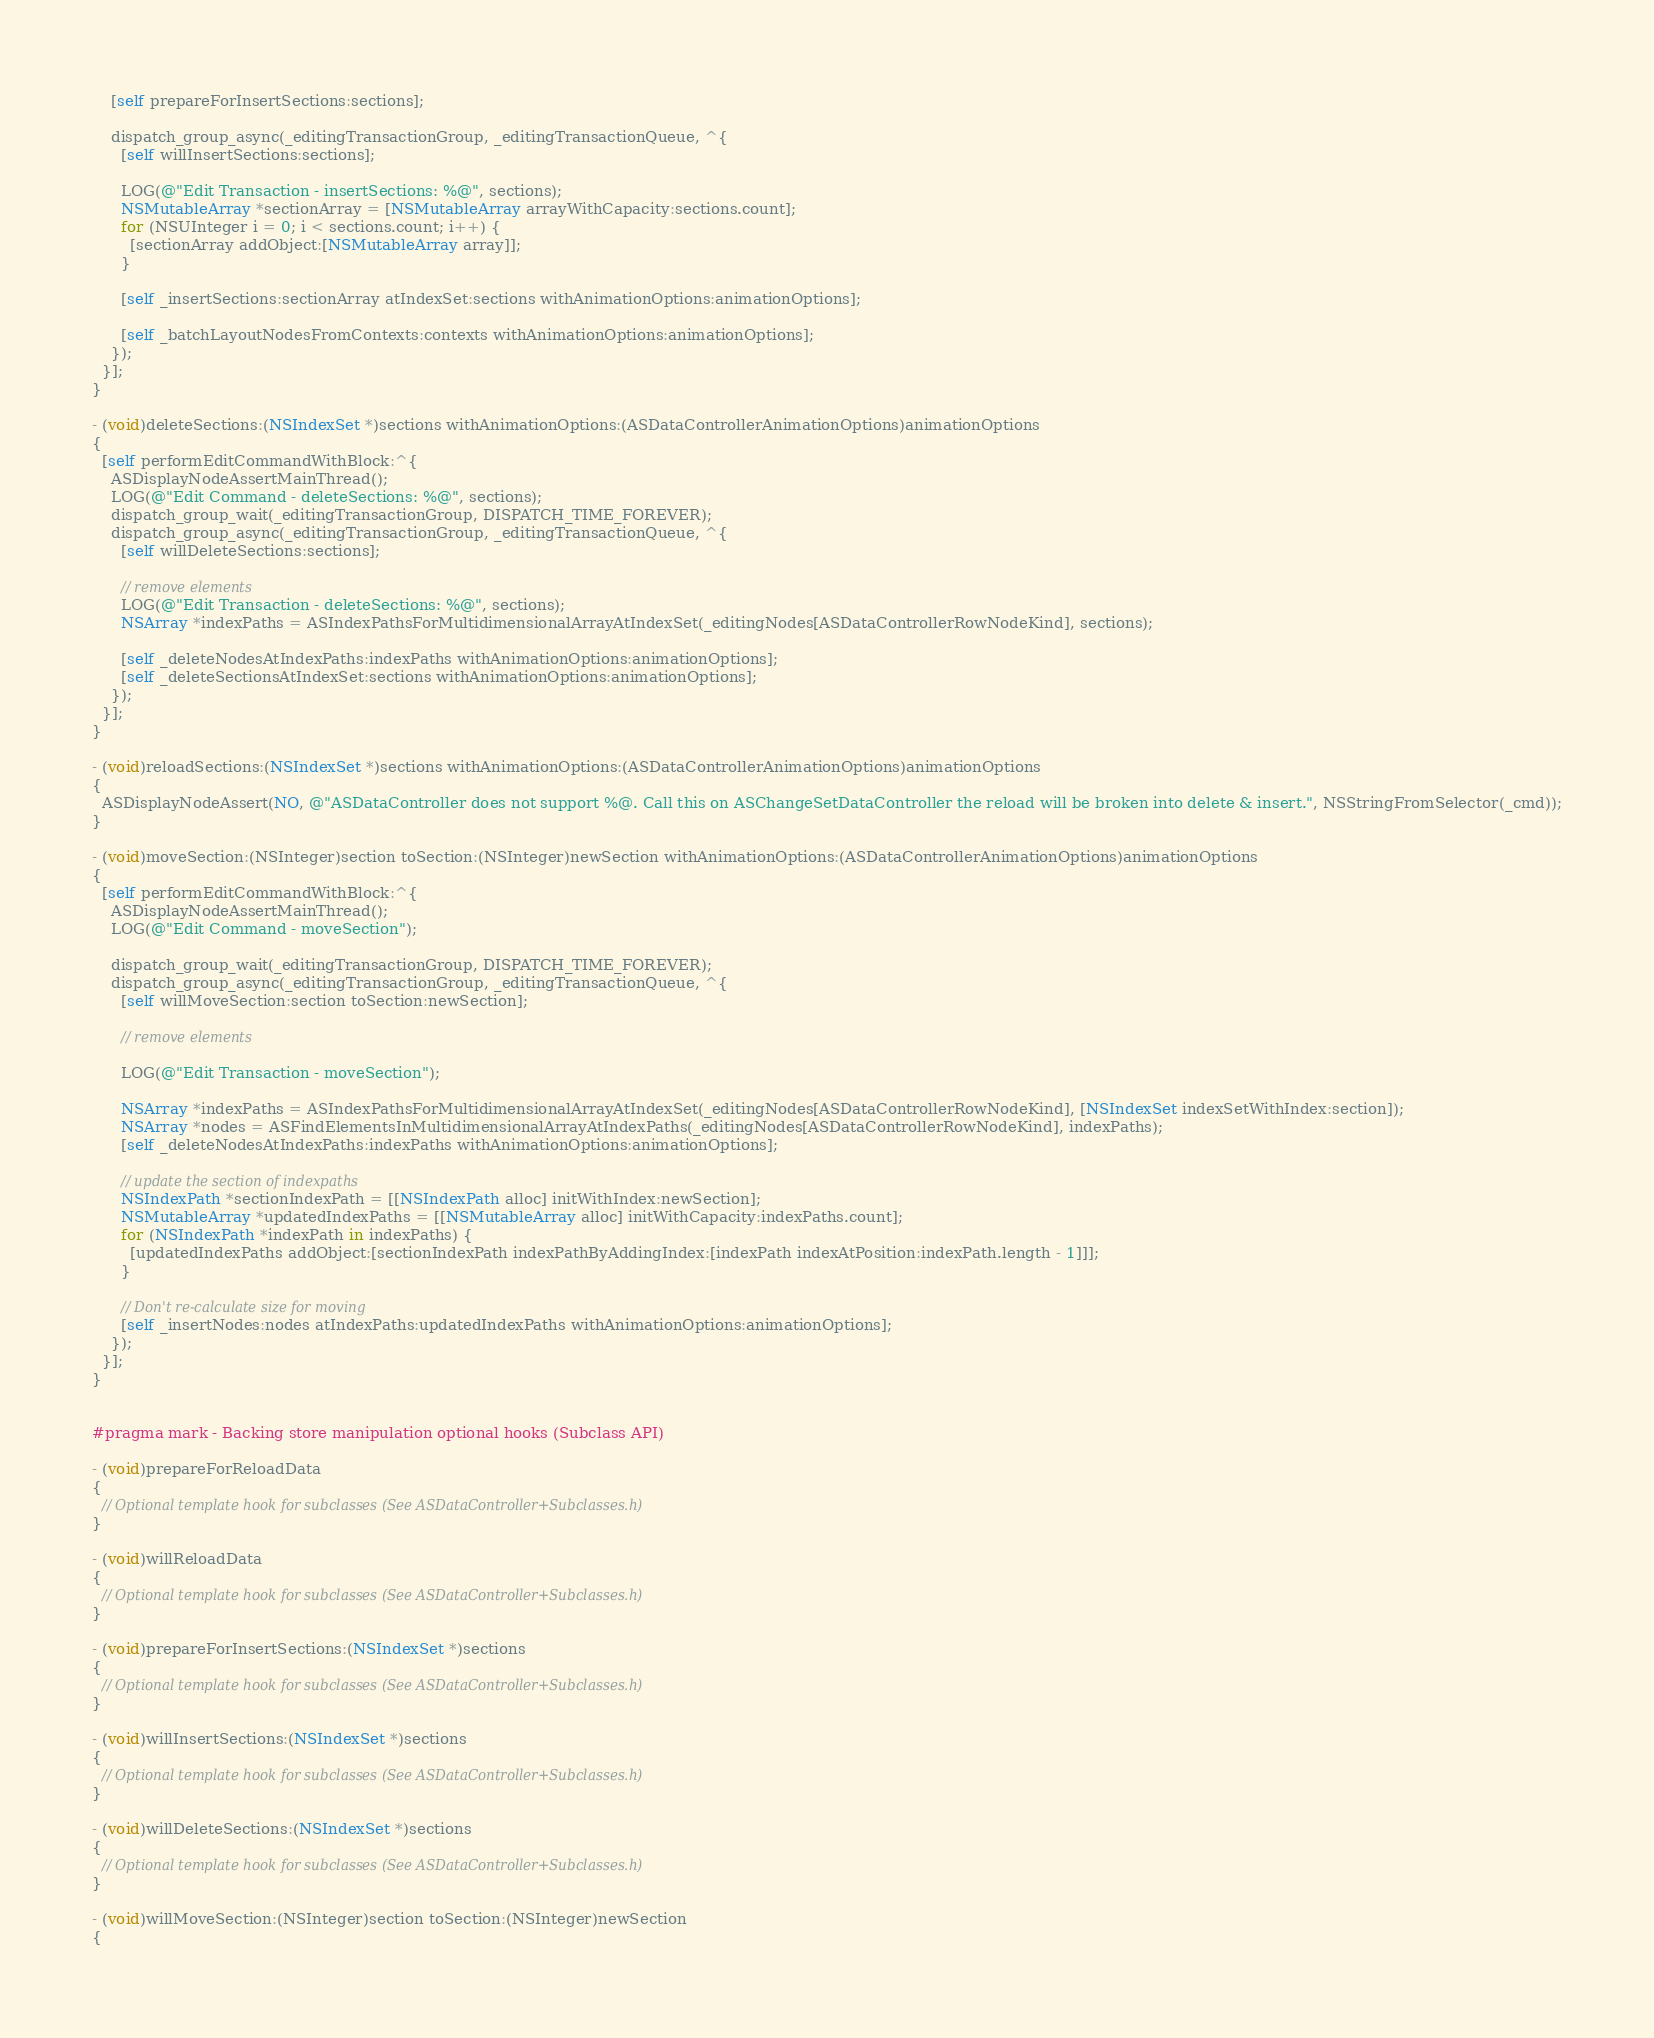<code> <loc_0><loc_0><loc_500><loc_500><_ObjectiveC_>    [self prepareForInsertSections:sections];
    
    dispatch_group_async(_editingTransactionGroup, _editingTransactionQueue, ^{
      [self willInsertSections:sections];

      LOG(@"Edit Transaction - insertSections: %@", sections);
      NSMutableArray *sectionArray = [NSMutableArray arrayWithCapacity:sections.count];
      for (NSUInteger i = 0; i < sections.count; i++) {
        [sectionArray addObject:[NSMutableArray array]];
      }

      [self _insertSections:sectionArray atIndexSet:sections withAnimationOptions:animationOptions];
      
      [self _batchLayoutNodesFromContexts:contexts withAnimationOptions:animationOptions];
    });
  }];
}

- (void)deleteSections:(NSIndexSet *)sections withAnimationOptions:(ASDataControllerAnimationOptions)animationOptions
{
  [self performEditCommandWithBlock:^{
    ASDisplayNodeAssertMainThread();
    LOG(@"Edit Command - deleteSections: %@", sections);
    dispatch_group_wait(_editingTransactionGroup, DISPATCH_TIME_FOREVER);
    dispatch_group_async(_editingTransactionGroup, _editingTransactionQueue, ^{
      [self willDeleteSections:sections];

      // remove elements
      LOG(@"Edit Transaction - deleteSections: %@", sections);
      NSArray *indexPaths = ASIndexPathsForMultidimensionalArrayAtIndexSet(_editingNodes[ASDataControllerRowNodeKind], sections);
      
      [self _deleteNodesAtIndexPaths:indexPaths withAnimationOptions:animationOptions];
      [self _deleteSectionsAtIndexSet:sections withAnimationOptions:animationOptions];
    });
  }];
}

- (void)reloadSections:(NSIndexSet *)sections withAnimationOptions:(ASDataControllerAnimationOptions)animationOptions
{
  ASDisplayNodeAssert(NO, @"ASDataController does not support %@. Call this on ASChangeSetDataController the reload will be broken into delete & insert.", NSStringFromSelector(_cmd));
}

- (void)moveSection:(NSInteger)section toSection:(NSInteger)newSection withAnimationOptions:(ASDataControllerAnimationOptions)animationOptions
{
  [self performEditCommandWithBlock:^{
    ASDisplayNodeAssertMainThread();
    LOG(@"Edit Command - moveSection");

    dispatch_group_wait(_editingTransactionGroup, DISPATCH_TIME_FOREVER);
    dispatch_group_async(_editingTransactionGroup, _editingTransactionQueue, ^{
      [self willMoveSection:section toSection:newSection];

      // remove elements
      
      LOG(@"Edit Transaction - moveSection");
      
      NSArray *indexPaths = ASIndexPathsForMultidimensionalArrayAtIndexSet(_editingNodes[ASDataControllerRowNodeKind], [NSIndexSet indexSetWithIndex:section]);
      NSArray *nodes = ASFindElementsInMultidimensionalArrayAtIndexPaths(_editingNodes[ASDataControllerRowNodeKind], indexPaths);
      [self _deleteNodesAtIndexPaths:indexPaths withAnimationOptions:animationOptions];

      // update the section of indexpaths
      NSIndexPath *sectionIndexPath = [[NSIndexPath alloc] initWithIndex:newSection];
      NSMutableArray *updatedIndexPaths = [[NSMutableArray alloc] initWithCapacity:indexPaths.count];
      for (NSIndexPath *indexPath in indexPaths) {
        [updatedIndexPaths addObject:[sectionIndexPath indexPathByAddingIndex:[indexPath indexAtPosition:indexPath.length - 1]]];
      }

      // Don't re-calculate size for moving
      [self _insertNodes:nodes atIndexPaths:updatedIndexPaths withAnimationOptions:animationOptions];
    });
  }];
}


#pragma mark - Backing store manipulation optional hooks (Subclass API)

- (void)prepareForReloadData
{
  // Optional template hook for subclasses (See ASDataController+Subclasses.h)
}

- (void)willReloadData
{
  // Optional template hook for subclasses (See ASDataController+Subclasses.h)
}

- (void)prepareForInsertSections:(NSIndexSet *)sections
{
  // Optional template hook for subclasses (See ASDataController+Subclasses.h)
}

- (void)willInsertSections:(NSIndexSet *)sections
{
  // Optional template hook for subclasses (See ASDataController+Subclasses.h)
}

- (void)willDeleteSections:(NSIndexSet *)sections
{
  // Optional template hook for subclasses (See ASDataController+Subclasses.h)
}

- (void)willMoveSection:(NSInteger)section toSection:(NSInteger)newSection
{</code> 